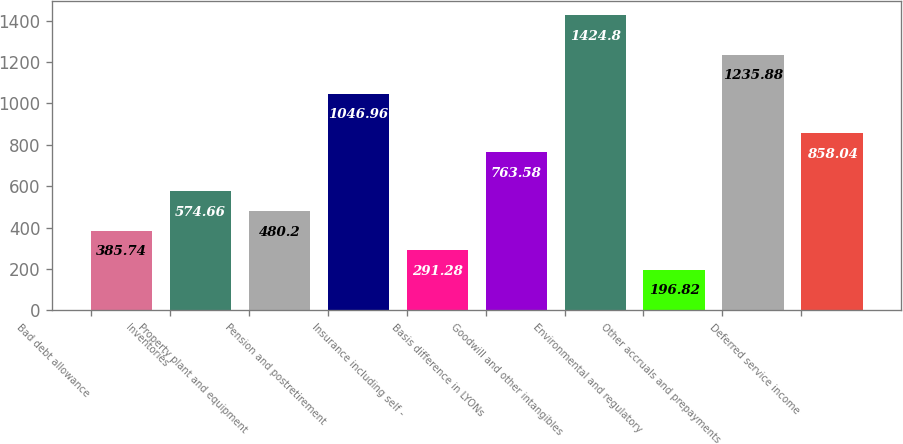<chart> <loc_0><loc_0><loc_500><loc_500><bar_chart><fcel>Bad debt allowance<fcel>Inventories<fcel>Property plant and equipment<fcel>Pension and postretirement<fcel>Insurance including self -<fcel>Basis difference in LYONs<fcel>Goodwill and other intangibles<fcel>Environmental and regulatory<fcel>Other accruals and prepayments<fcel>Deferred service income<nl><fcel>385.74<fcel>574.66<fcel>480.2<fcel>1046.96<fcel>291.28<fcel>763.58<fcel>1424.8<fcel>196.82<fcel>1235.88<fcel>858.04<nl></chart> 